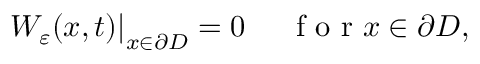<formula> <loc_0><loc_0><loc_500><loc_500>W _ { \varepsilon } ( x , t ) \right | _ { x \in \partial D } = 0 \quad f o r x \in \partial D ,</formula> 